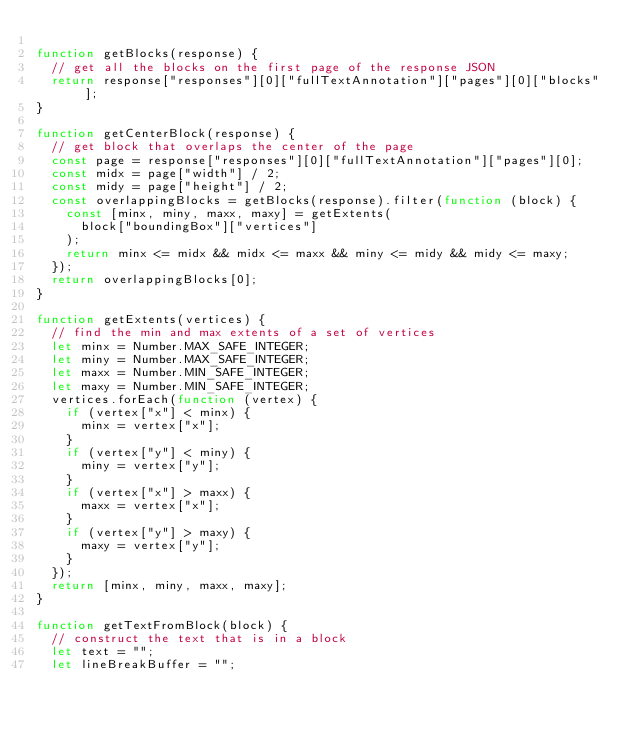Convert code to text. <code><loc_0><loc_0><loc_500><loc_500><_JavaScript_>
function getBlocks(response) {
  // get all the blocks on the first page of the response JSON
  return response["responses"][0]["fullTextAnnotation"]["pages"][0]["blocks"];
}

function getCenterBlock(response) {
  // get block that overlaps the center of the page
  const page = response["responses"][0]["fullTextAnnotation"]["pages"][0];
  const midx = page["width"] / 2;
  const midy = page["height"] / 2;
  const overlappingBlocks = getBlocks(response).filter(function (block) {
    const [minx, miny, maxx, maxy] = getExtents(
      block["boundingBox"]["vertices"]
    );
    return minx <= midx && midx <= maxx && miny <= midy && midy <= maxy;
  });
  return overlappingBlocks[0];
}

function getExtents(vertices) {
  // find the min and max extents of a set of vertices
  let minx = Number.MAX_SAFE_INTEGER;
  let miny = Number.MAX_SAFE_INTEGER;
  let maxx = Number.MIN_SAFE_INTEGER;
  let maxy = Number.MIN_SAFE_INTEGER;
  vertices.forEach(function (vertex) {
    if (vertex["x"] < minx) {
      minx = vertex["x"];
    }
    if (vertex["y"] < miny) {
      miny = vertex["y"];
    }
    if (vertex["x"] > maxx) {
      maxx = vertex["x"];
    }
    if (vertex["y"] > maxy) {
      maxy = vertex["y"];
    }
  });
  return [minx, miny, maxx, maxy];
}

function getTextFromBlock(block) {
  // construct the text that is in a block
  let text = "";
  let lineBreakBuffer = "";</code> 